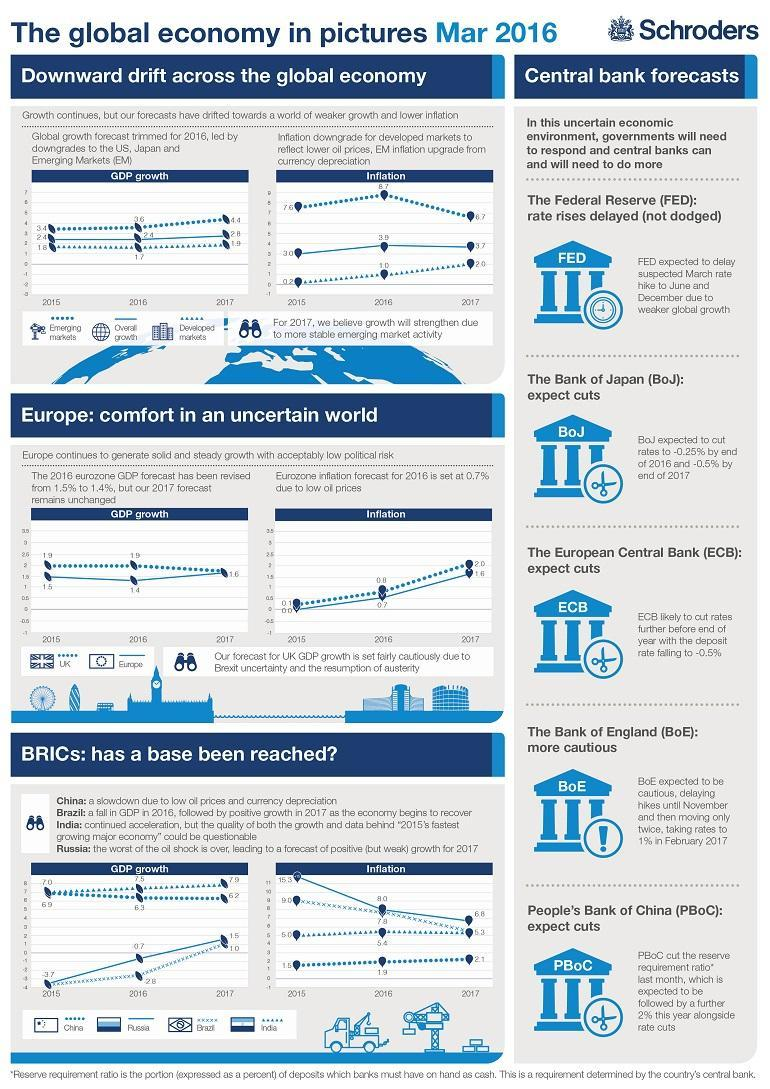which country in BRICS has shown the most stable Inflation between 2015 to 2017
Answer the question with a short phrase. India what are the 2 different markets for which GDP has been shown in global economy Emerging markets, Developed markets WHich are the countries in BRICS other than India China, Brazil, Russia what has been the inflation in developed markets in 2016 1.0 How much has the inflation fallen for Brazil from 2015 to 2017 3.7 what is the GDP difference of Russia from 2016 to 2017 0.8 WHat has been the GDP for developed markets in 2016 1.7 